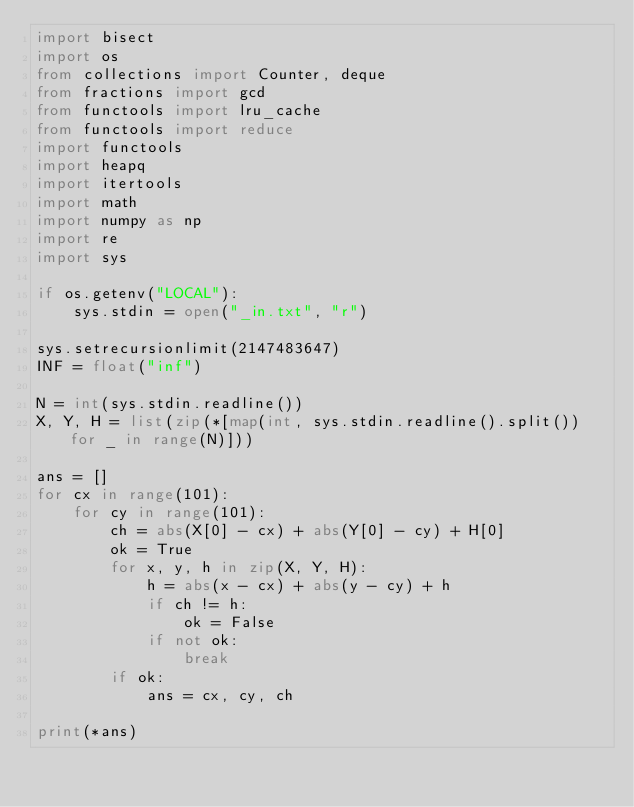Convert code to text. <code><loc_0><loc_0><loc_500><loc_500><_Python_>import bisect
import os
from collections import Counter, deque
from fractions import gcd
from functools import lru_cache
from functools import reduce
import functools
import heapq
import itertools
import math
import numpy as np
import re
import sys

if os.getenv("LOCAL"):
    sys.stdin = open("_in.txt", "r")

sys.setrecursionlimit(2147483647)
INF = float("inf")

N = int(sys.stdin.readline())
X, Y, H = list(zip(*[map(int, sys.stdin.readline().split()) for _ in range(N)]))

ans = []
for cx in range(101):
    for cy in range(101):
        ch = abs(X[0] - cx) + abs(Y[0] - cy) + H[0]
        ok = True
        for x, y, h in zip(X, Y, H):
            h = abs(x - cx) + abs(y - cy) + h
            if ch != h:
                ok = False
            if not ok:
                break
        if ok:
            ans = cx, cy, ch

print(*ans)
</code> 